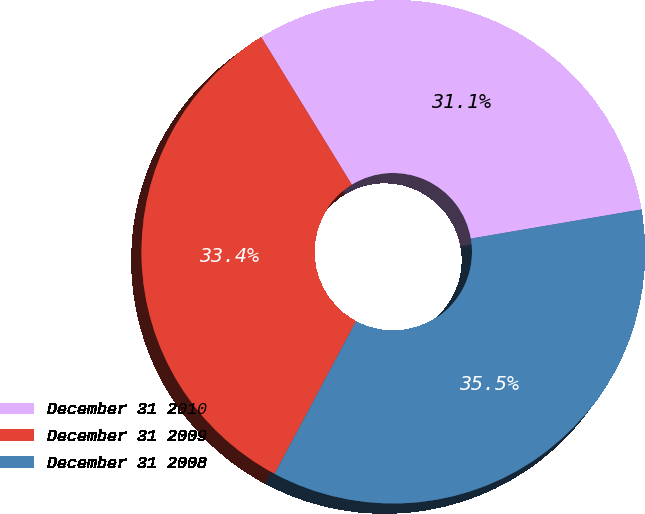<chart> <loc_0><loc_0><loc_500><loc_500><pie_chart><fcel>December 31 2010<fcel>December 31 2009<fcel>December 31 2008<nl><fcel>31.07%<fcel>33.43%<fcel>35.5%<nl></chart> 